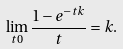<formula> <loc_0><loc_0><loc_500><loc_500>\lim _ { t 0 } \frac { 1 - e ^ { - t k } } { t } = k .</formula> 